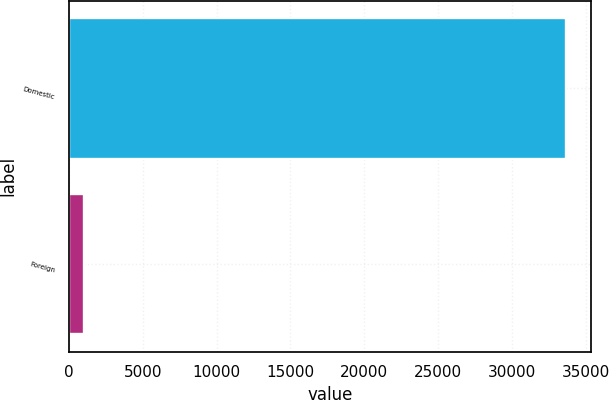<chart> <loc_0><loc_0><loc_500><loc_500><bar_chart><fcel>Domestic<fcel>Foreign<nl><fcel>33662<fcel>1033<nl></chart> 